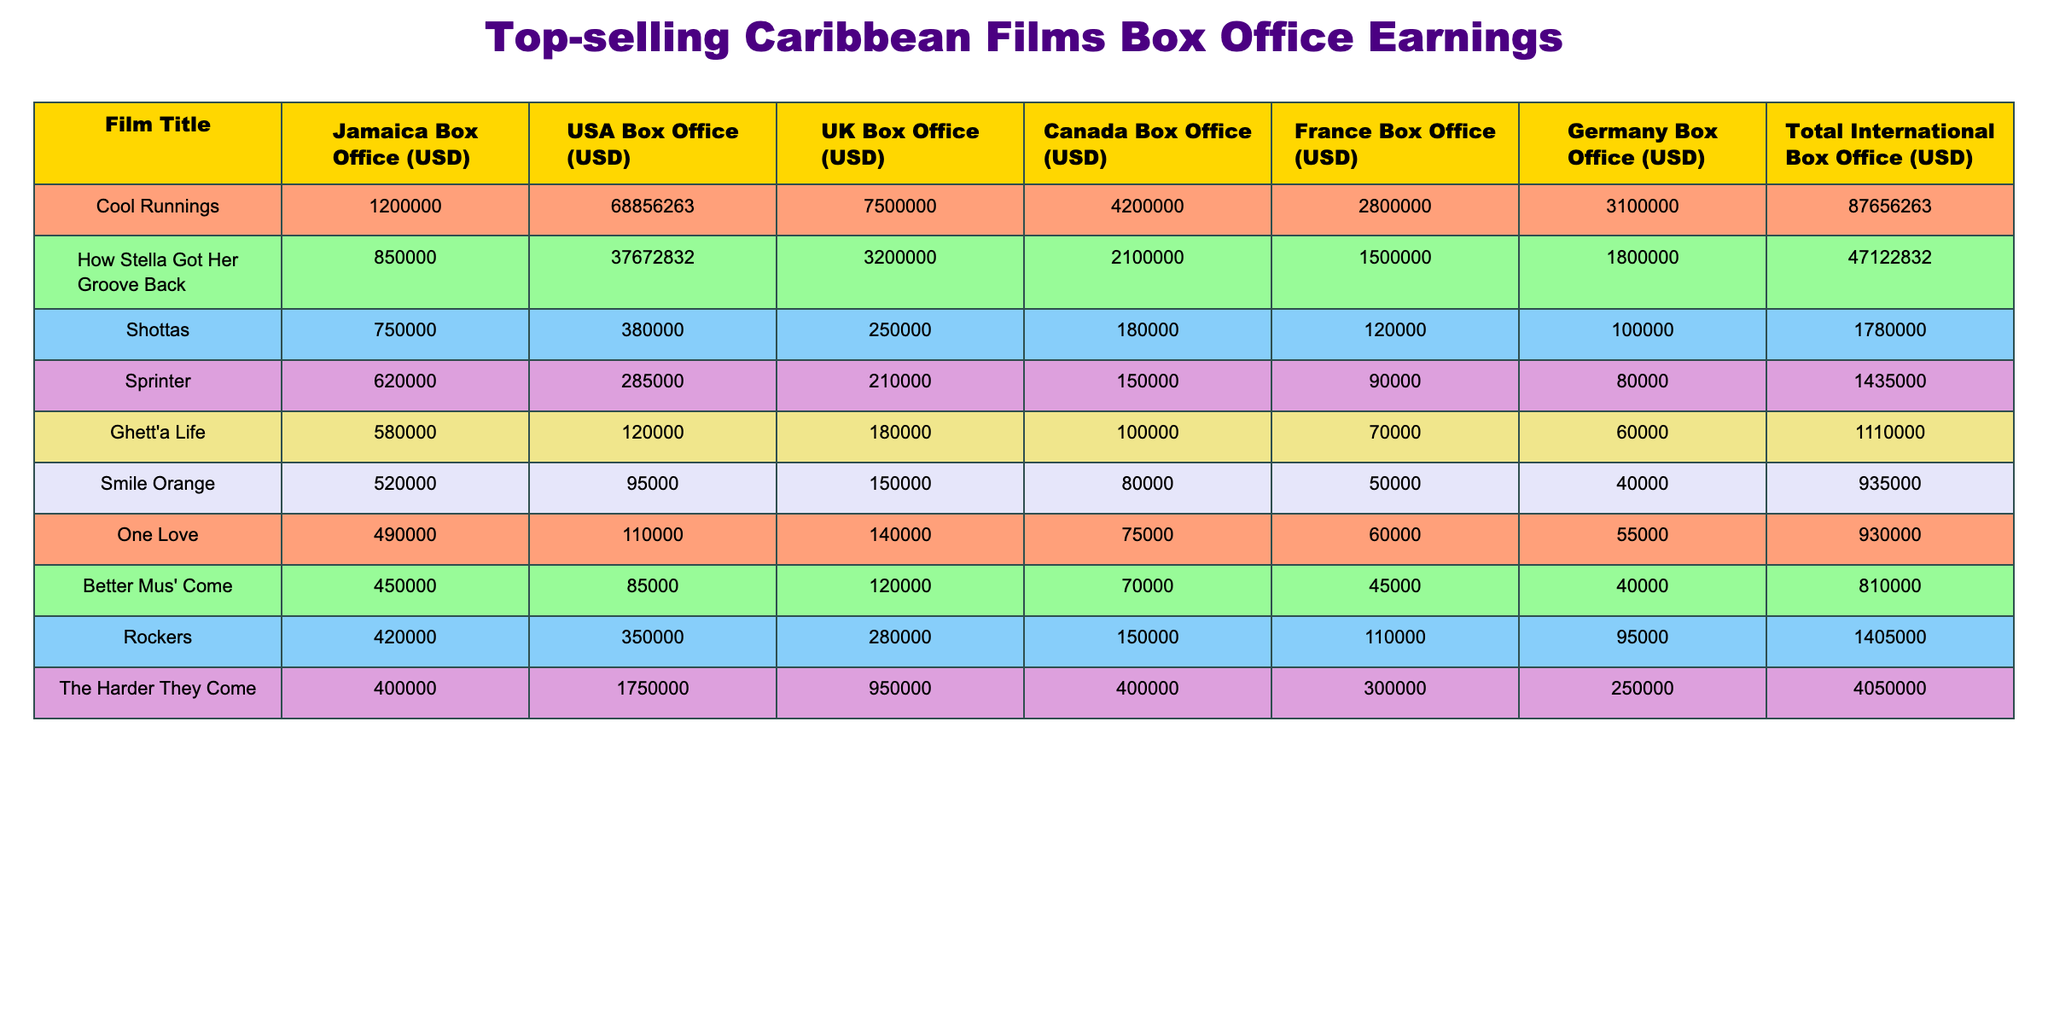What is the total box office earning of "Cool Runnings"? To find this, we can look at the "Total International Box Office" column for "Cool Runnings" which is listed as $87,656,263.
Answer: 87,656,263 Which film had the highest USA box office earnings? The USA box office earnings for each film are listed, and "How Stella Got Her Groove Back" has the highest at $37,672,832.
Answer: 37,672,832 How much did "Ghett'a Life" earn in total from all markets combined? To find the total earnings, we check the "Total International Box Office" for "Ghett'a Life," which is $1,110,000.
Answer: 1,110,000 Is "Smile Orange" more successful than "One Love" in terms of total box office earnings? "Smile Orange" total earnings are $935,000, while "One Love" earned $930,000. So yes, "Smile Orange" is slightly more successful.
Answer: Yes What is the difference in box office earnings between "How Stella Got Her Groove Back" and "One Love"? "How Stella Got Her Groove Back" earned $47,122,832 and "One Love" earned $930,000. The difference is $47,122,832 - $930,000 = $46,192,832.
Answer: 46,192,832 Which film had more than $2 million in box office earnings from the USA market? We can compare the USA earnings. Only "How Stella Got Her Groove Back" had over $2 million, as its earnings are $37,672,832.
Answer: Yes What is the average box office earnings of the films from Jamaica? We sum the Jamaica box office earnings: 1,200,000 + 850,000 + 750,000 + 620,000 + 580,000 + 520,000 + 490,000 + 450,000 + 420,000 + 400,000 = 5,490,000. There are 10 films, so the average is 5,490,000 / 10 = 549,000.
Answer: 549,000 Which film had the lowest total international box office earnings? By examining the "Total International Box Office" column, "Better Mus' Come" shows the lowest total of $810,000.
Answer: Better Mus' Come How much did the film "Rockers" earn in the UK market? Checking the UK box office earnings for "Rockers" we can see it earned $280,000.
Answer: 280,000 If all films except "Shottas" were removed, what would be the new total international box office earnings? The total earnings for all films is $132,106,263. Subtract "Shottas" earnings of $1,780,000 from this total gives us $132,106,263 - $1,780,000 = $130,326,263.
Answer: 130,326,263 